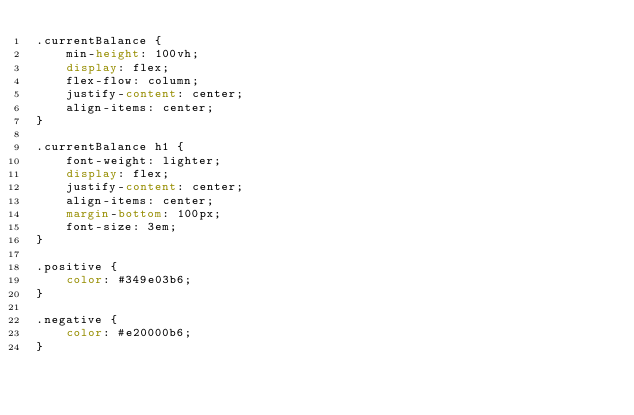Convert code to text. <code><loc_0><loc_0><loc_500><loc_500><_CSS_>.currentBalance {
    min-height: 100vh;
    display: flex;
    flex-flow: column;
    justify-content: center;
    align-items: center;
}

.currentBalance h1 {
    font-weight: lighter;
    display: flex;
    justify-content: center;
    align-items: center;
    margin-bottom: 100px;
    font-size: 3em;
}

.positive {
    color: #349e03b6;
}

.negative {
    color: #e20000b6;
}
</code> 